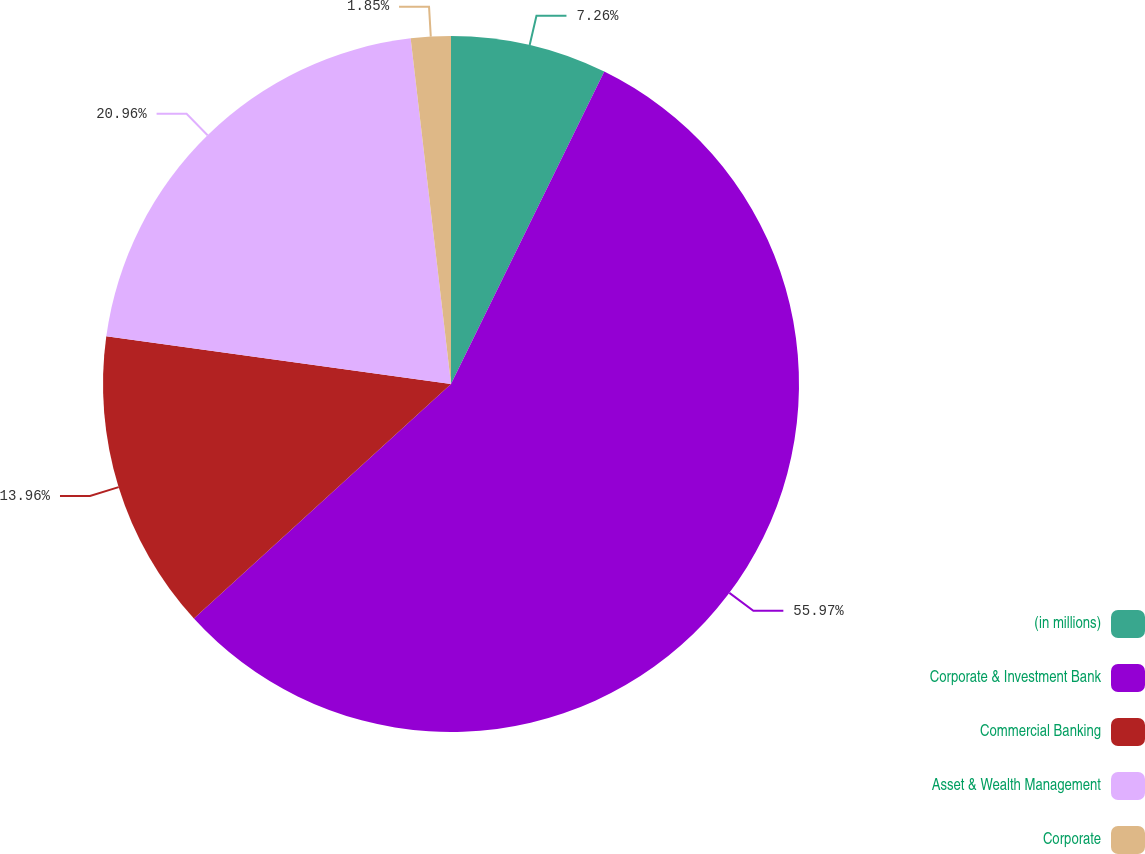Convert chart to OTSL. <chart><loc_0><loc_0><loc_500><loc_500><pie_chart><fcel>(in millions)<fcel>Corporate & Investment Bank<fcel>Commercial Banking<fcel>Asset & Wealth Management<fcel>Corporate<nl><fcel>7.26%<fcel>55.97%<fcel>13.96%<fcel>20.96%<fcel>1.85%<nl></chart> 